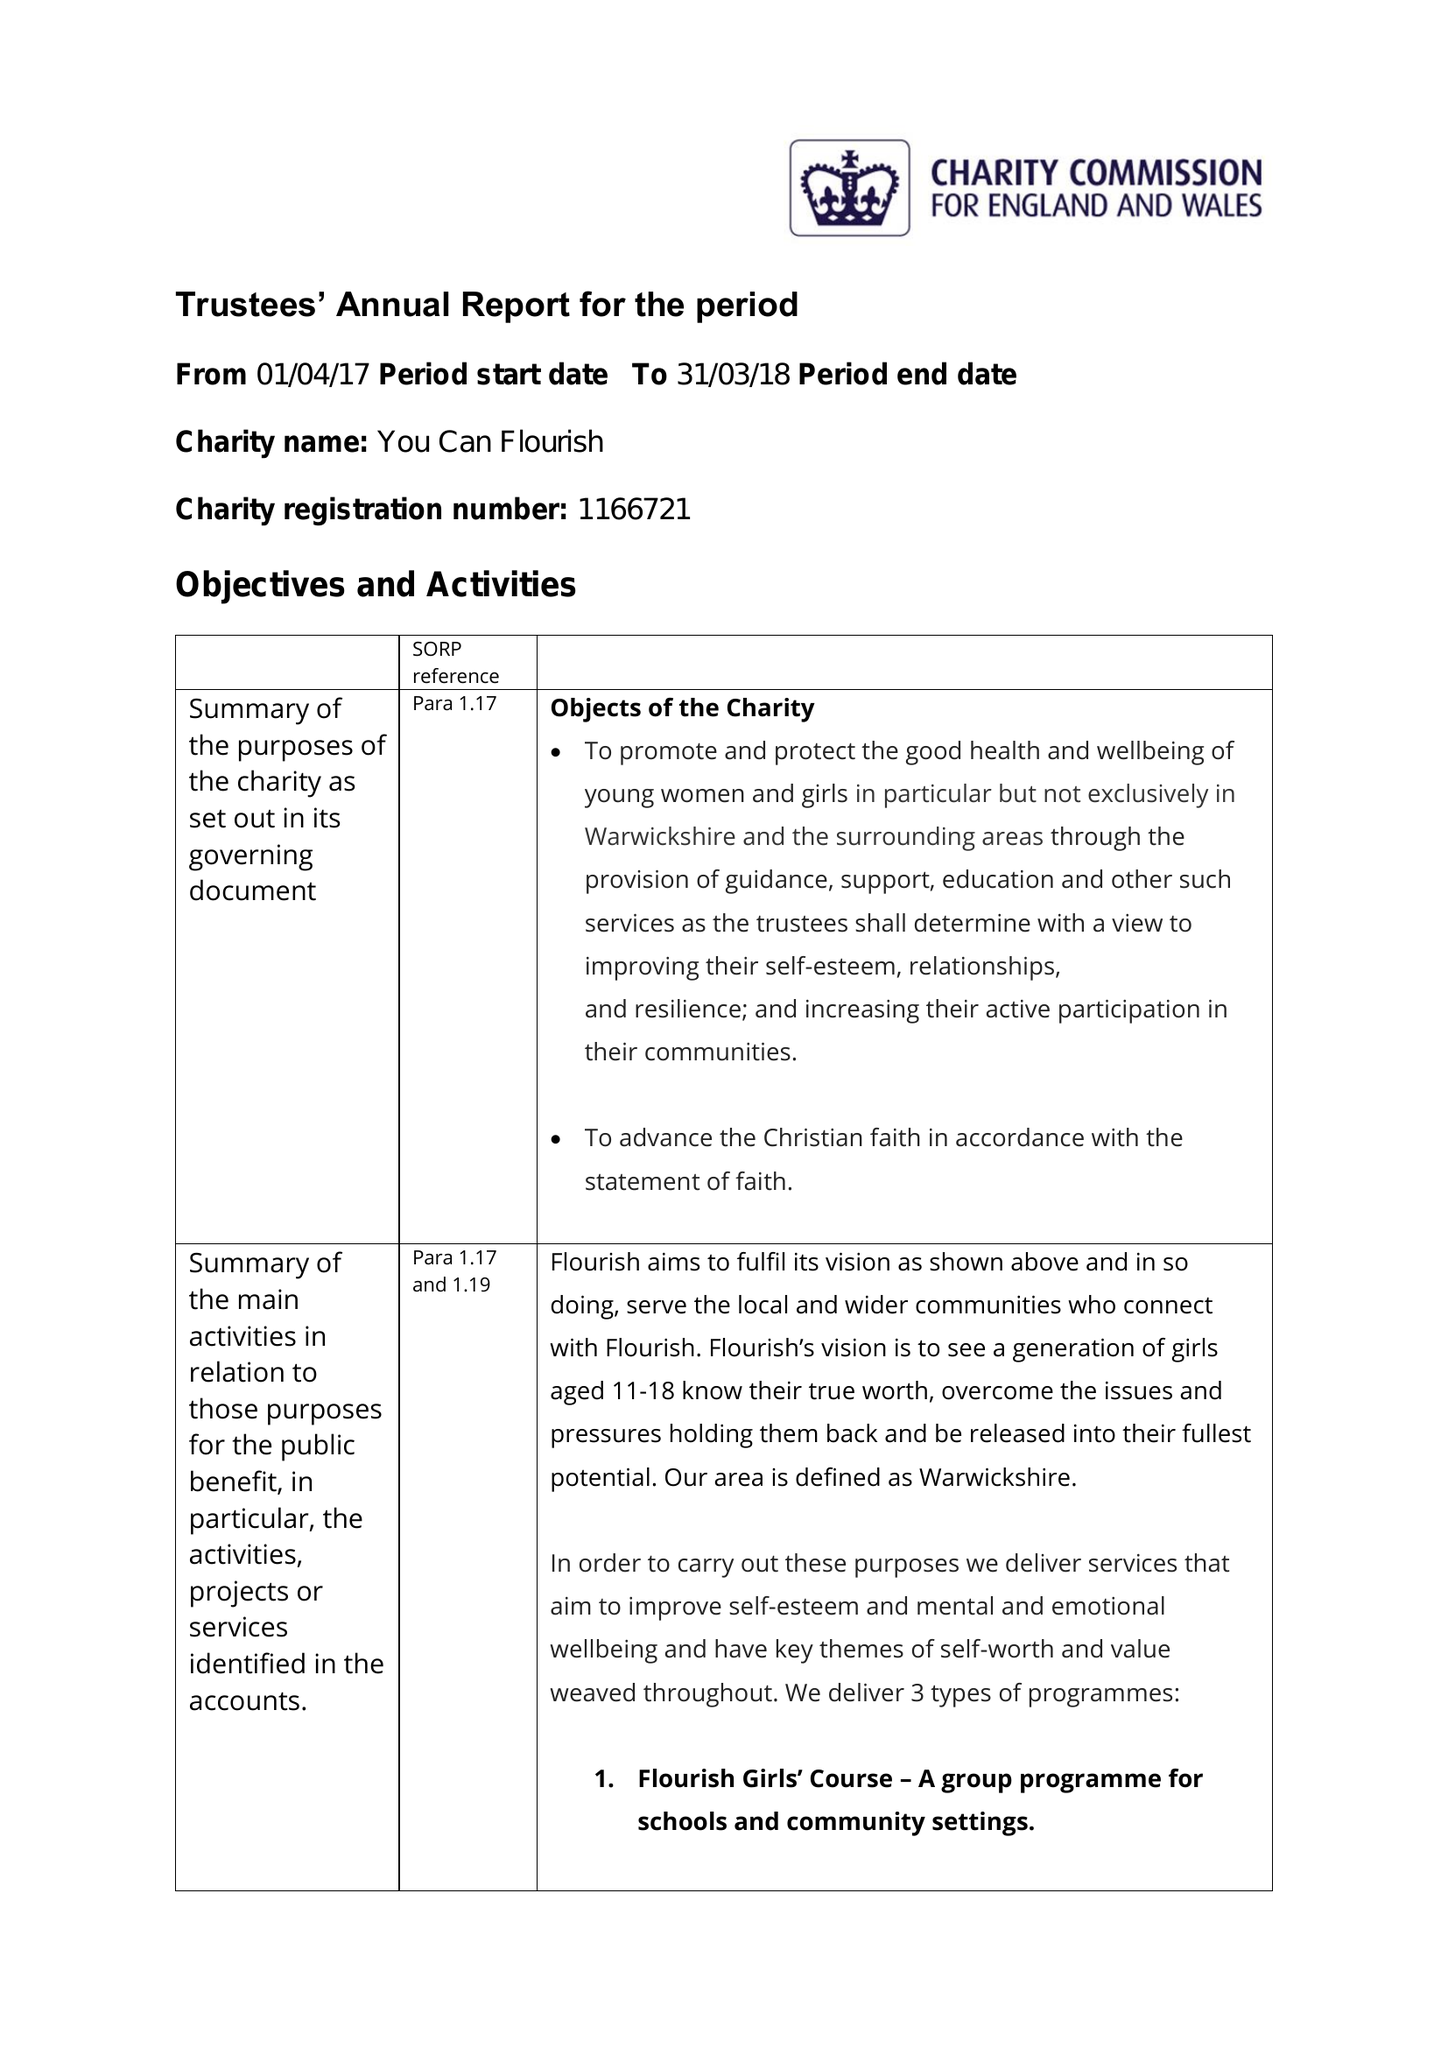What is the value for the address__street_line?
Answer the question using a single word or phrase. None 